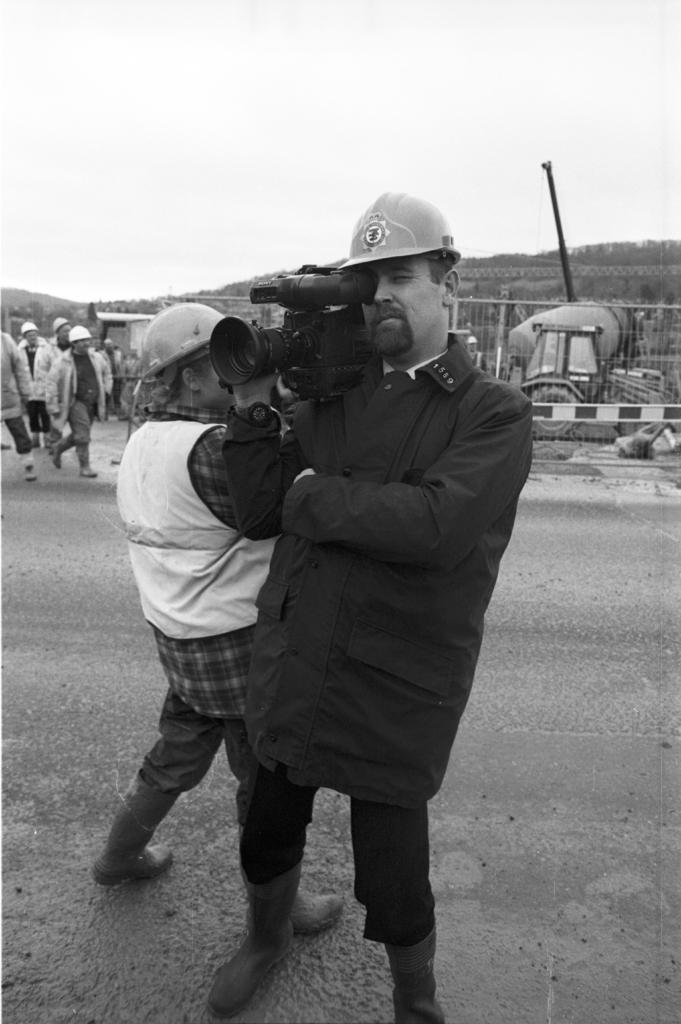What can be observed about the people in the image? There are people standing in the image, and they are wearing clothes, shoes, and helmets. What equipment is present in the image? There is a video camera in the image. What type of barrier can be seen in the image? There is a fence in the image. What natural elements are visible in the image? Trees and the sky are visible in the image. What type of path is present in the image? There is a footpath in the image. What mode of transportation is present in the image? There is a vehicle in the image. What type of worm can be seen crawling on the vehicle in the image? There is no worm present in the image; only people, a video camera, a fence, trees, the sky, a footpath, and a vehicle are visible. 